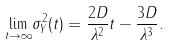Convert formula to latex. <formula><loc_0><loc_0><loc_500><loc_500>\underset { t \rightarrow \infty } { \lim } \sigma _ { Y } ^ { 2 } ( t ) = \frac { 2 D } { \lambda ^ { 2 } } t - \frac { 3 D } { \lambda ^ { 3 } } .</formula> 